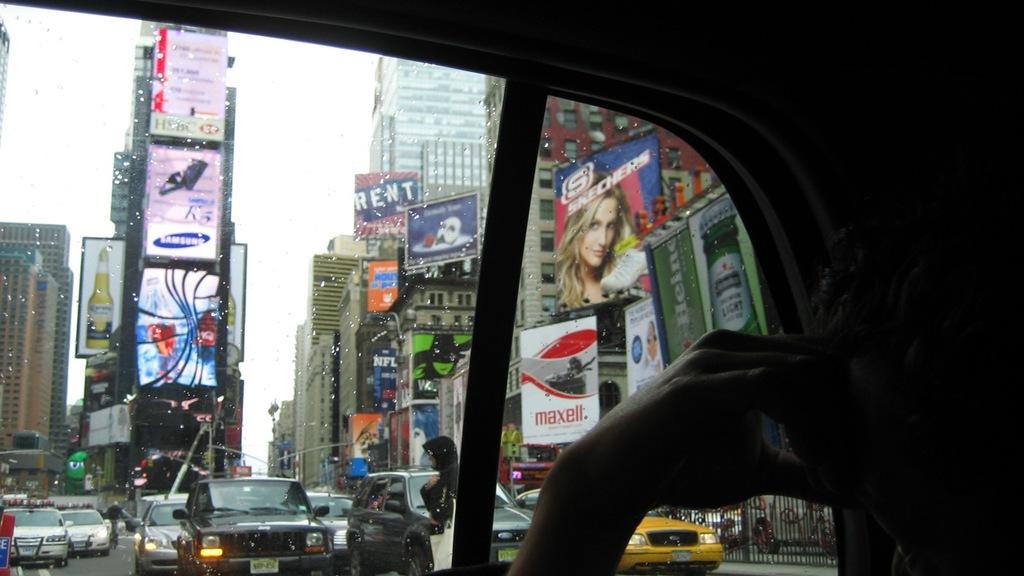Which company is advertised on the white and red sign?
Give a very brief answer. Maxell. Is there a sign advertising rent?
Provide a short and direct response. Yes. 